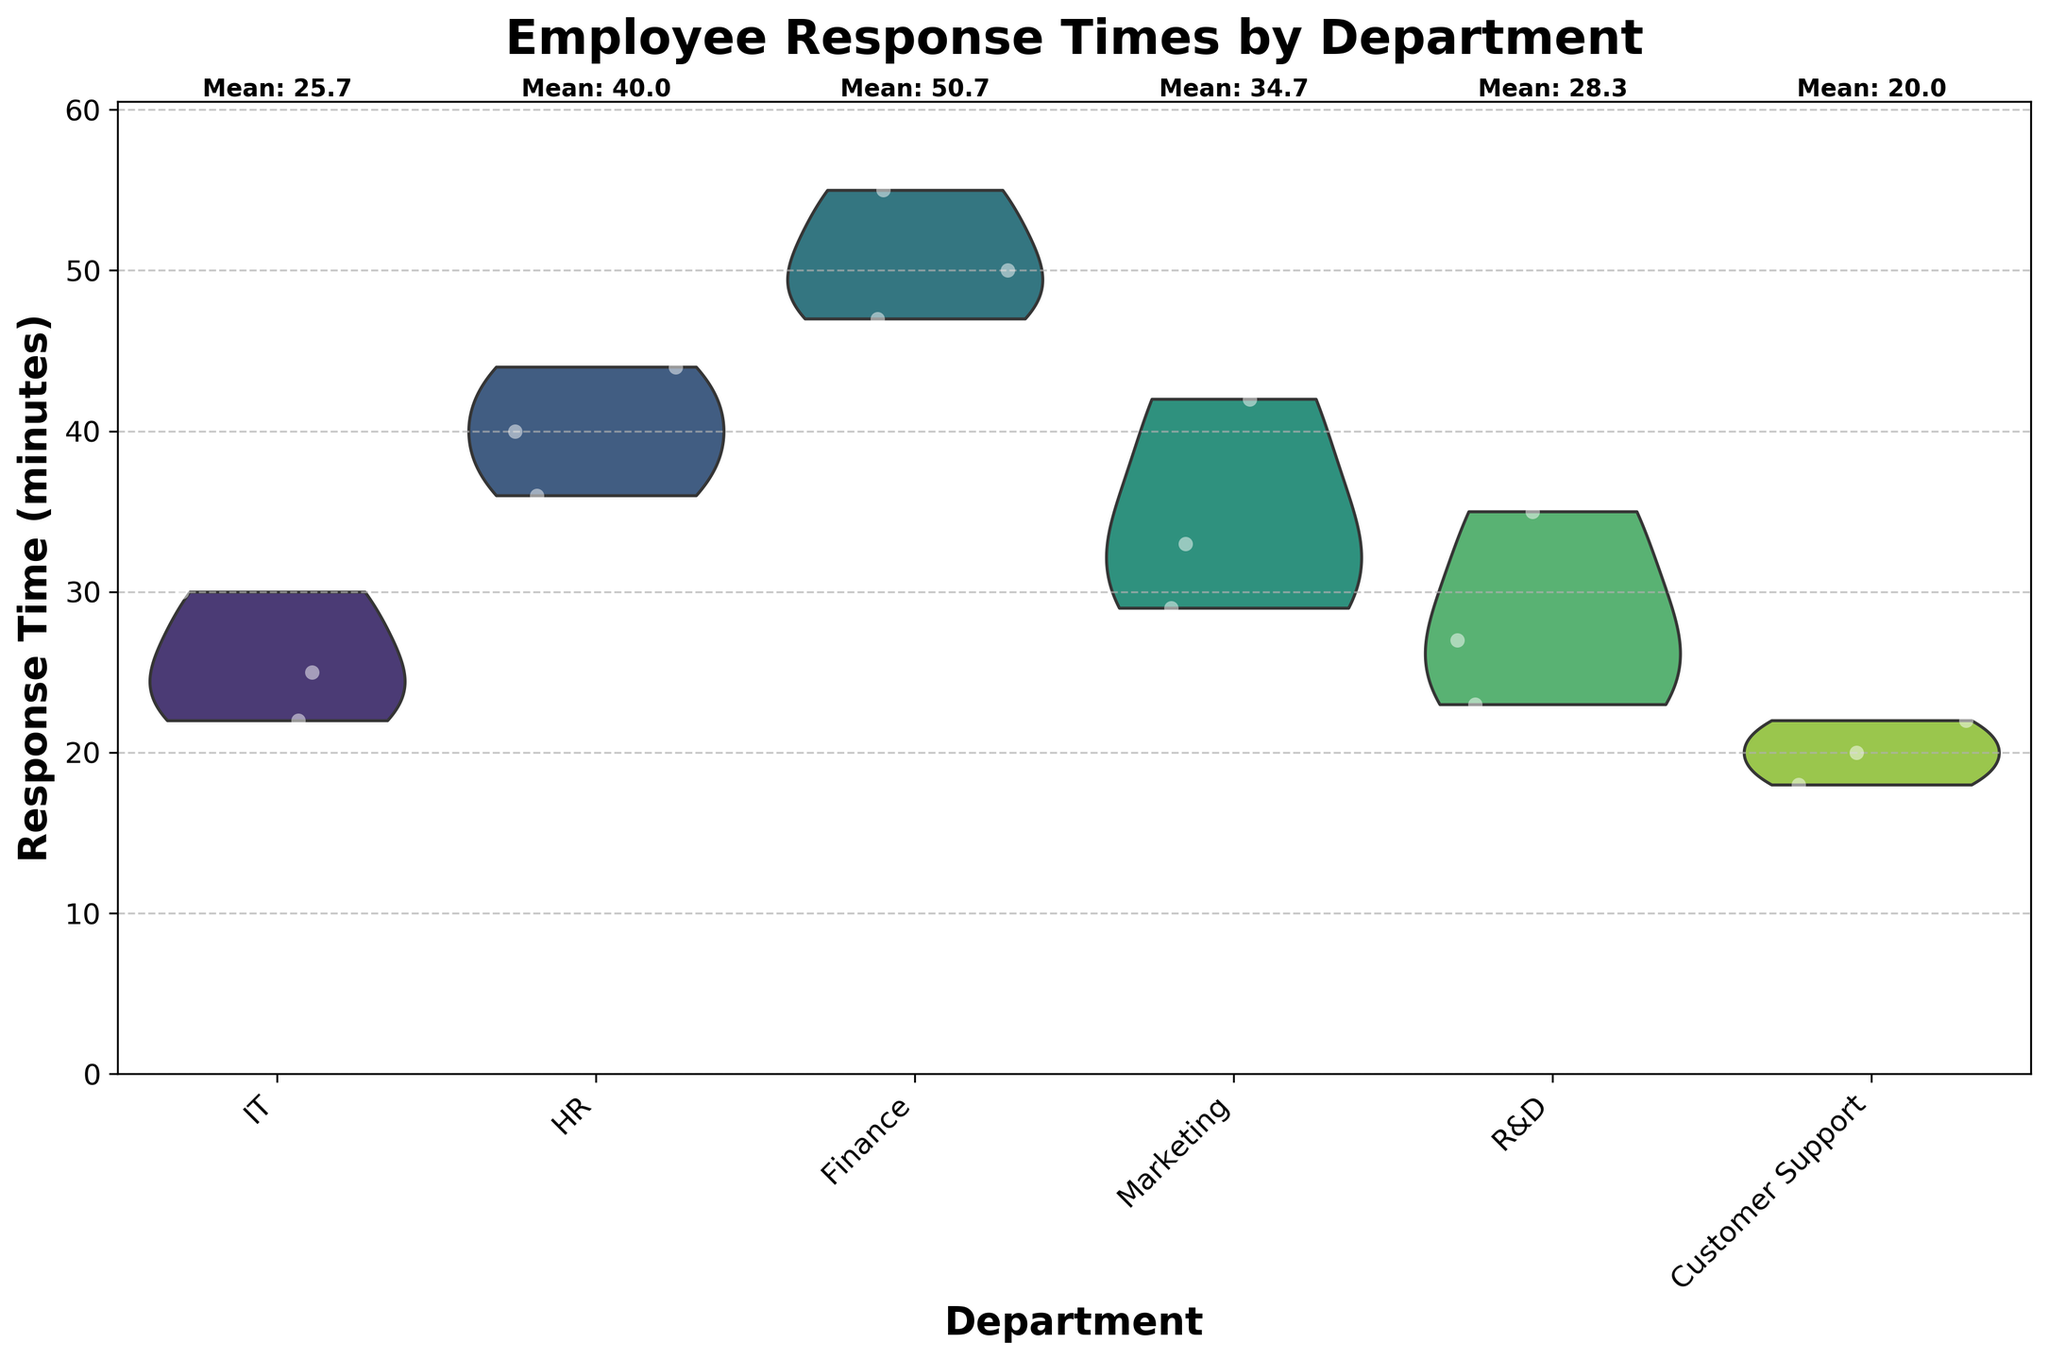What's the title of the figure? The title of the figure is usually visible at the top and provides a summary of what the figure is about. Here, the title reads "Employee Response Times by Department."
Answer: Employee Response Times by Department What is the y-axis labeled as? The y-axis label is located beside the vertical axis, which describes what the axis represents. The label here reads "Response Time (minutes)."
Answer: Response Time (minutes) Which department has the highest mean response time, and what is it? To find this, observe the mean response times noted above each department's violin plot. The Finance department has the highest mean response time written as 'Mean: 50.7'.
Answer: Finance, 50.7 Which department shows the widest range of response times? The widest range of response times can be observed by looking at the vertical extent of the violin plots. The Finance department shows a range from around 45 to 55 minutes, which is the widest range.
Answer: Finance Which departments have employees with response times less than 20 minutes? From the jittered points within the violin plots, identify departments where any points fall below the 20-minute mark. Customer Support has multiple employees clocking in under 20 minutes.
Answer: Customer Support What is the mean response time for the IT department? Refer to the text annotated above the IT department's violin plot which mentions the mean response time. It states 'Mean: 25.7'.
Answer: 25.7 Which department has the narrowest distribution of response times? The narrowest distribution can be determined by observing the width of the violin plot. The IT department has the narrowest distribution since it does not spread out much horizontally.
Answer: IT How do the response times in the HR and Marketing departments compare? Compare the violin plots of the HR and Marketing departments by looking at their spread and mean values. HR has a higher mean response time than Marketing, and its distribution also has higher values overall.
Answer: HR has higher response times than Marketing What is the range of response times for the R&D department? Look at the spread of the jittered points and the violin plot for R&D. The range in the R&D department goes from approximately 23 to 35 minutes.
Answer: 23 to 35 minutes Are there any departments with mean response times close to 30 minutes? Check the mean values noted above each violin plot for departments with means around 30. The IT department's mean of 25.7 and Marketing department's mean of 34.7 are closest to 30 minutes.
Answer: IT, Marketing 